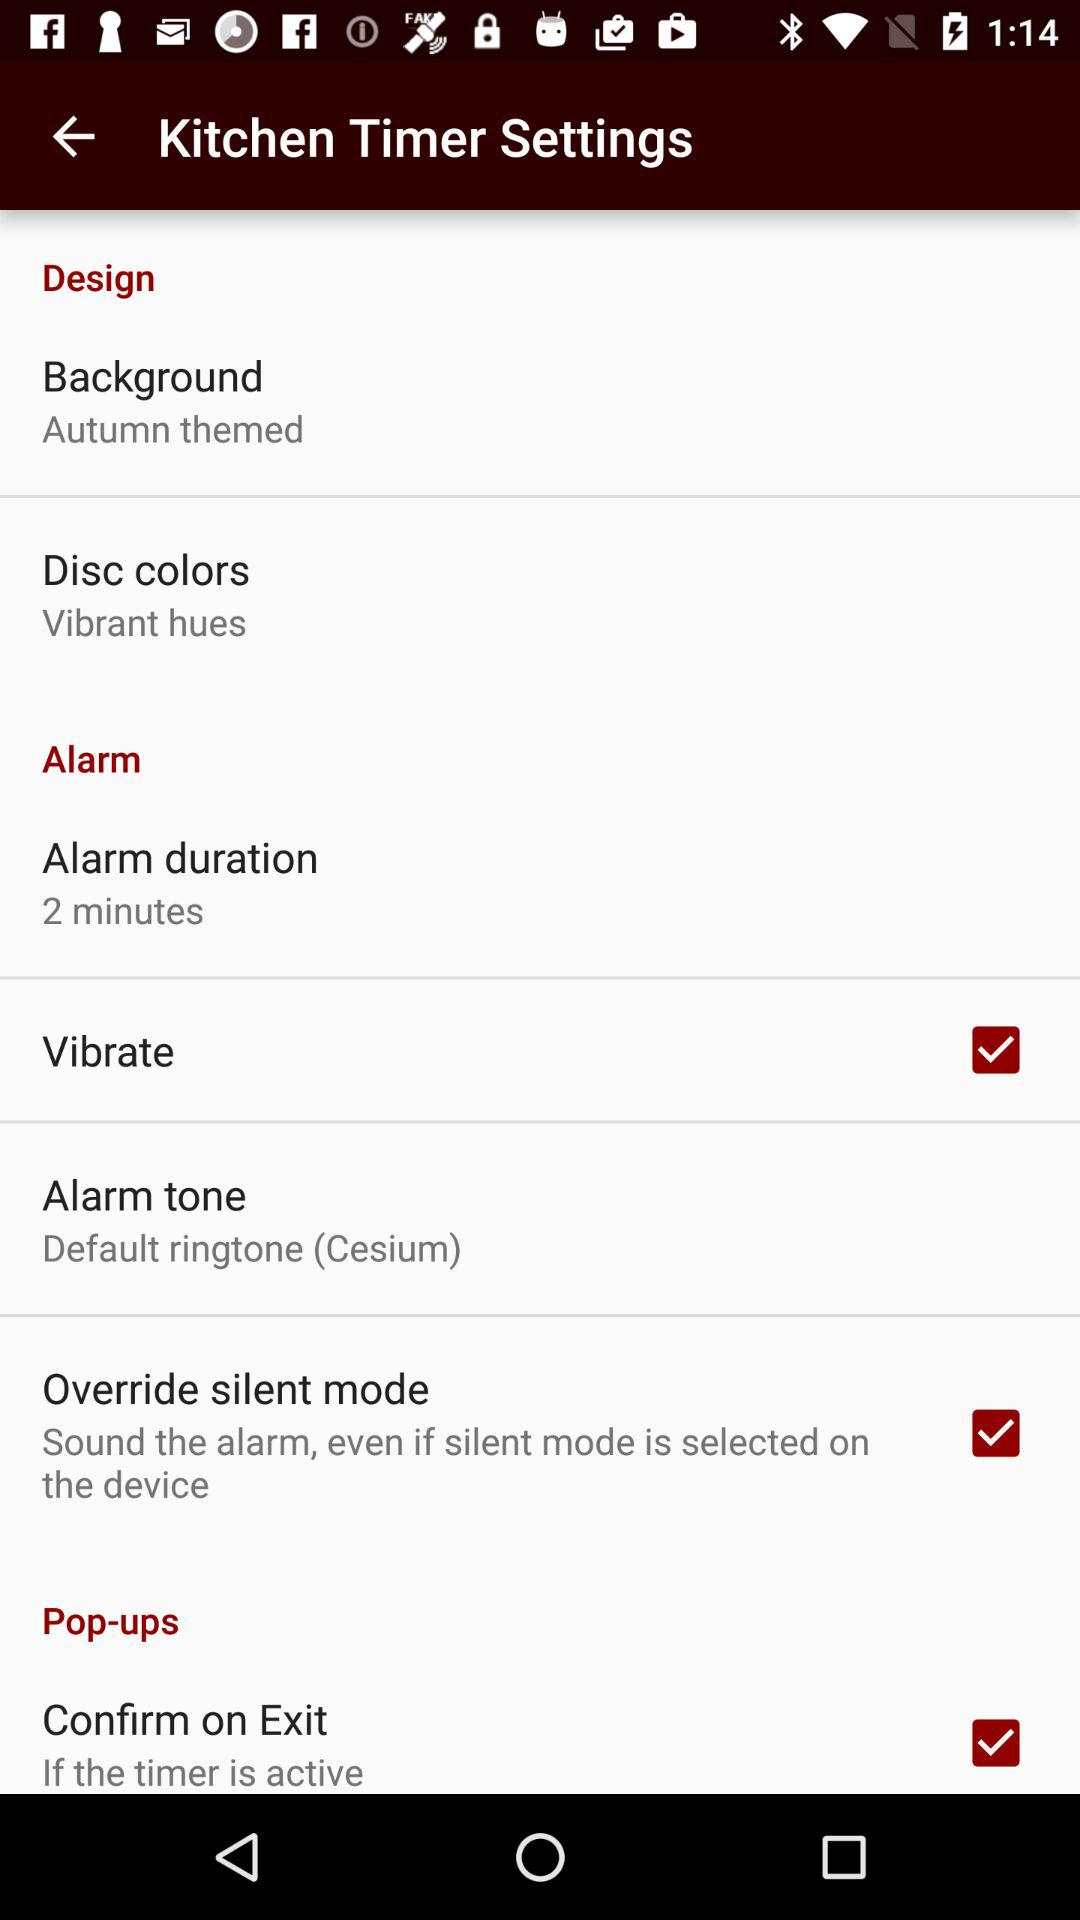What is the background theme? The background theme is "Autumn themed". 